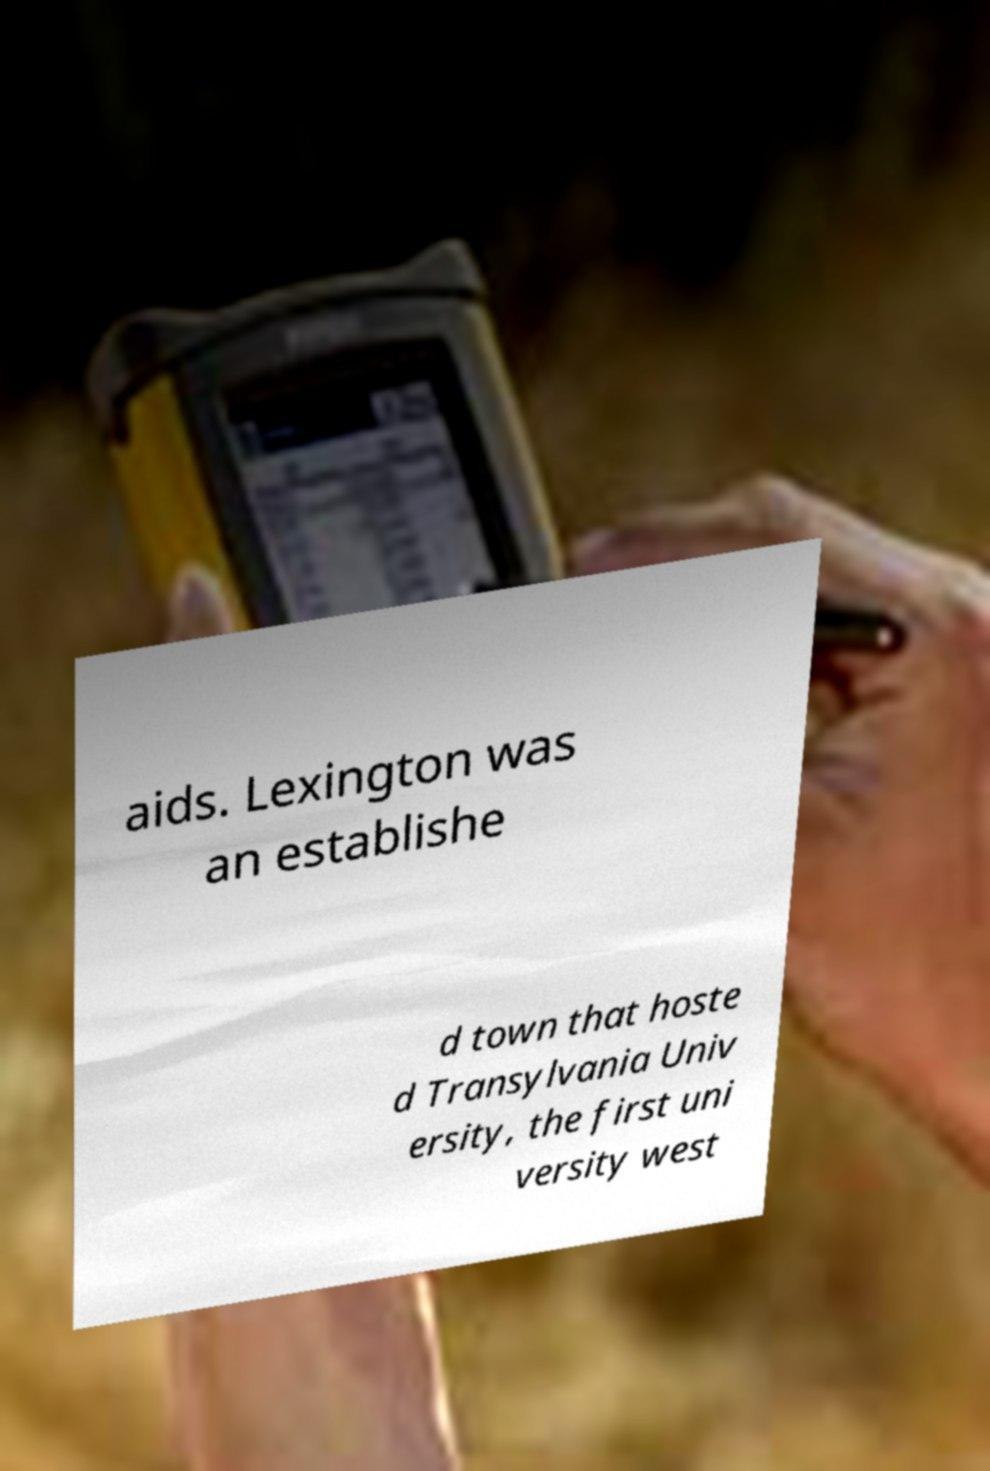Could you extract and type out the text from this image? aids. Lexington was an establishe d town that hoste d Transylvania Univ ersity, the first uni versity west 